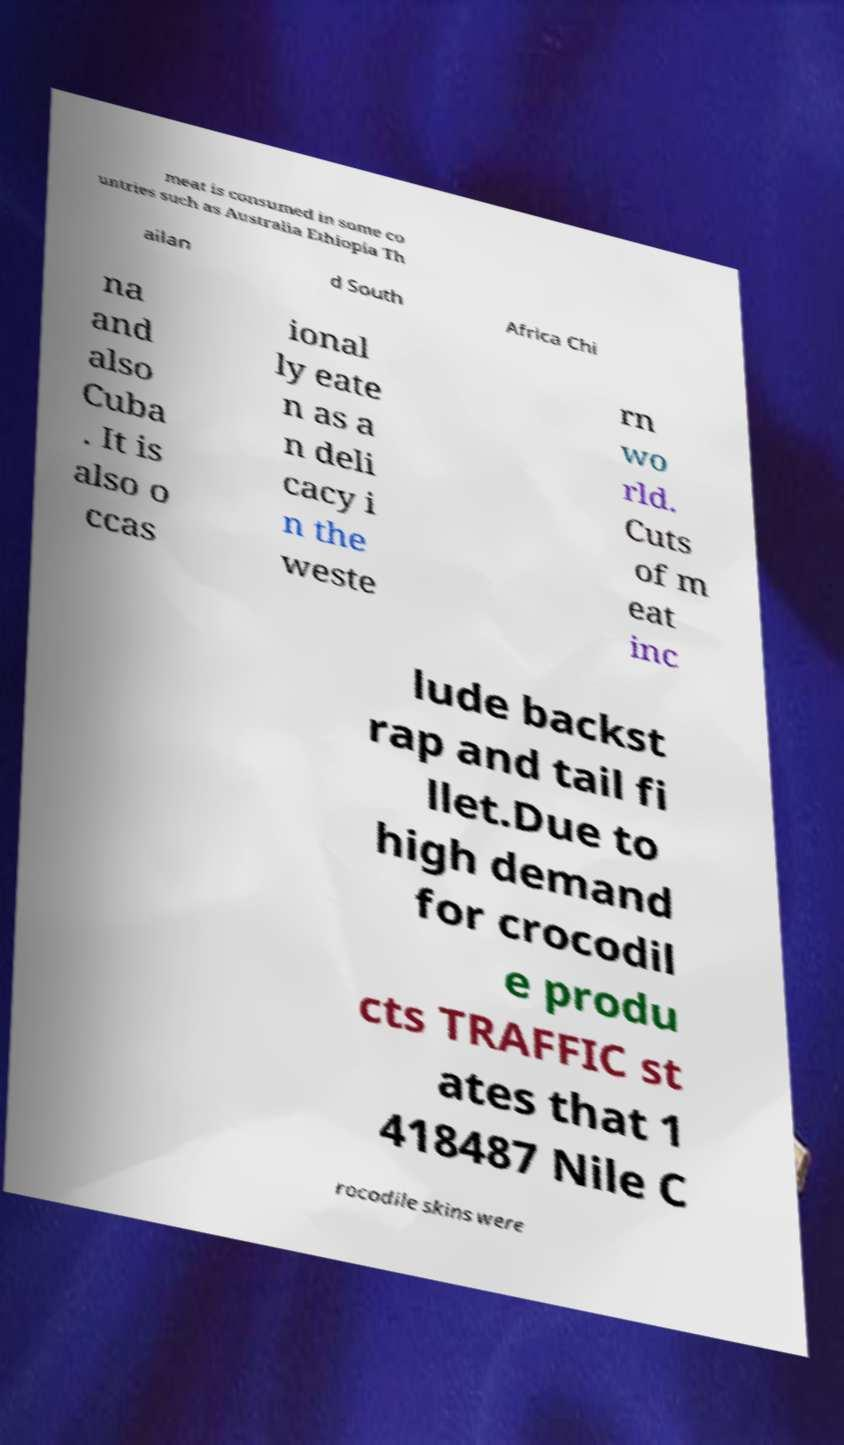Please read and relay the text visible in this image. What does it say? meat is consumed in some co untries such as Australia Ethiopia Th ailan d South Africa Chi na and also Cuba . It is also o ccas ional ly eate n as a n deli cacy i n the weste rn wo rld. Cuts of m eat inc lude backst rap and tail fi llet.Due to high demand for crocodil e produ cts TRAFFIC st ates that 1 418487 Nile C rocodile skins were 